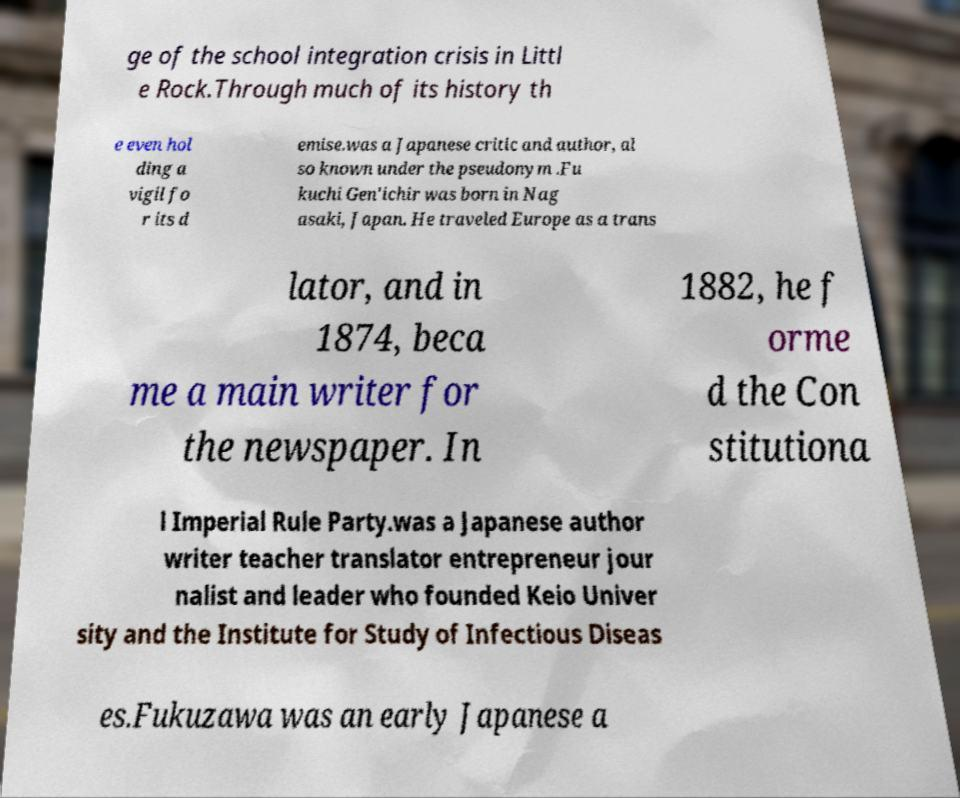There's text embedded in this image that I need extracted. Can you transcribe it verbatim? ge of the school integration crisis in Littl e Rock.Through much of its history th e even hol ding a vigil fo r its d emise.was a Japanese critic and author, al so known under the pseudonym .Fu kuchi Gen'ichir was born in Nag asaki, Japan. He traveled Europe as a trans lator, and in 1874, beca me a main writer for the newspaper. In 1882, he f orme d the Con stitutiona l Imperial Rule Party.was a Japanese author writer teacher translator entrepreneur jour nalist and leader who founded Keio Univer sity and the Institute for Study of Infectious Diseas es.Fukuzawa was an early Japanese a 